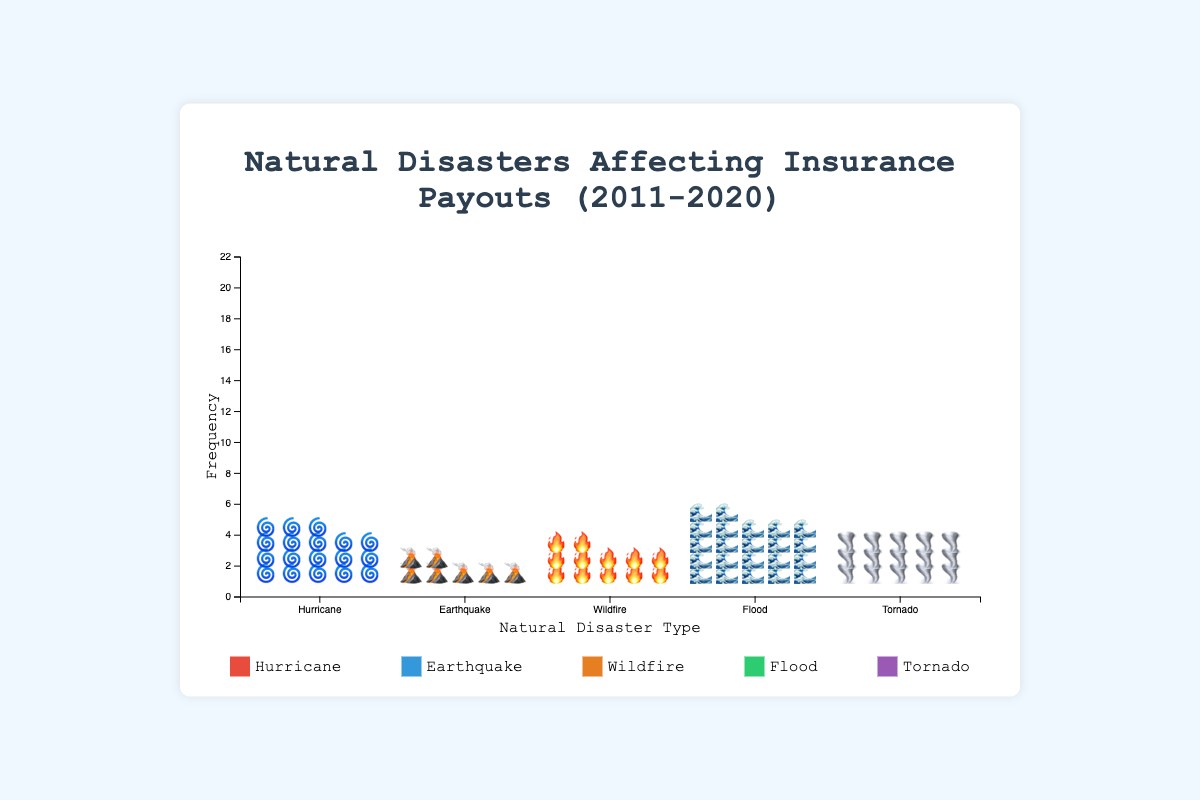What is the most frequent natural disaster depicted in the figure? The frequency of natural disasters in the figure is visualized through the number of icons stacked vertically for each disaster type. 'Flood' has the most icons, indicating it is the most frequent.
Answer: Flood What color represents Wildfires in the plot? Each disaster type has a specific color in the plot. Wildfires are represented by the color orange.
Answer: Orange How many hurricanes occurred over the past decade? The frequency of hurricanes is shown by the number of hurricane icons. The figure shows 18 hurricane icons.
Answer: 18 Which natural disaster has the highest average insurance payout? The figure displays both the frequency and average payouts for natural disasters, but we need to look at the labels for average payouts. Hurricanes have an average insurance payout of $2500 million, which is the highest.
Answer: Hurricane How do the frequencies of Earthquakes and Tornadoes compare? The frequency of earthquakes is less than tornadoes. The figure shows 7 icons for earthquakes and 15 icons for tornadoes.
Answer: Earthquakes less than Tornadoes What is the total number of natural disasters depicted in the figure? Adding up the frequency numbers: 18 (Hurricane) + 7 (Earthquake) + 12 (Wildfire) + 22 (Flood) + 15 (Tornado) gives a total of 74 natural disasters.
Answer: 74 Which natural disaster has the lowest average payout, and what is it? By looking at the labeled average payout amounts, Tornadoes have the lowest average payout of $600 million.
Answer: Tornado, $600 million How many more wildfires were there compared to earthquakes? The figure shows 12 icons for wildfires and 7 for earthquakes. The difference is 12 - 7 = 5.
Answer: 5 Are the frequencies of Wildfires and Tornadoes closer to each other compared to Earthquakes and Hurricanes? Comparing the frequencies, Wildfires (12) and Tornadoes (15) have a difference of 3, while Earthquakes (7) and Hurricanes (18) have a difference of 11. Wildfires and Tornadoes are indeed closer in frequency.
Answer: Yes What do the icons represent in the Isotype Plot? The icons represent the frequency of different natural disasters affecting insurance payouts over the past decade. Each icon indicates one occurrence of a disaster.
Answer: Frequency of occurrences 